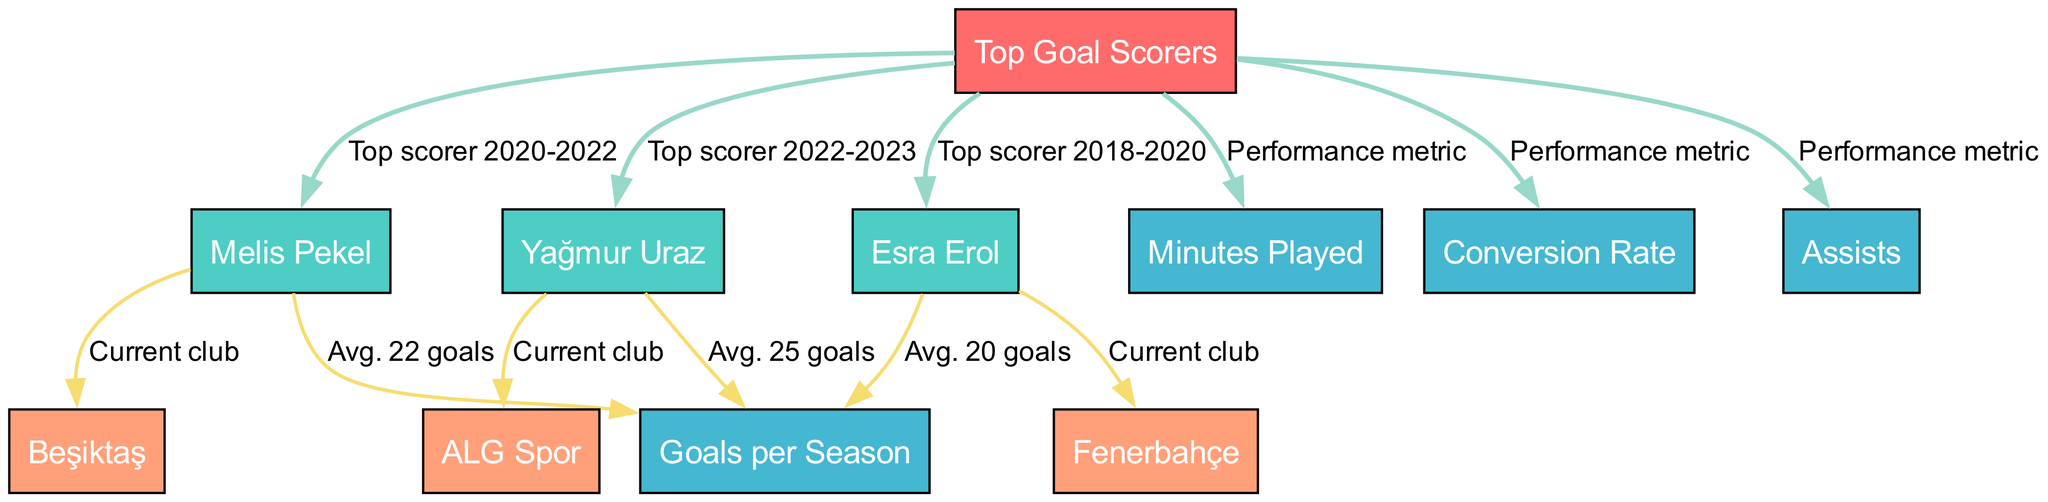What is the average number of goals scored by Melis Pekel? From the diagram, we can see that Melis Pekel has an average of 22 goals, as indicated by the edge connecting her node to the "Goals per Season" node.
Answer: 22 goals Who is the top scorer for the 2022-2023 season? The diagram shows that Yağmur Uraz is labeled as the top scorer for the 2022-2023 season, as indicated by the edge connecting her node to the "Top Goal Scorers" node.
Answer: Yağmur Uraz Which club does Esra Erol currently play for? According to the diagram, Esra Erol's node connects to "Fenerbahçe," indicating that she currently plays for this club.
Answer: Fenerbahçe How many performance metrics are represented in the diagram? The diagram includes three performance metrics: "Minutes Played," "Conversion Rate," and "Assists," which are all connected to the "Top Goal Scorers" node.
Answer: 3 Which player has the highest average goals? The diagram states that Yağmur Uraz has an average of 25 goals, which is higher than Melis Pekel's 22 goals and Esra Erol's 20 goals, as seen through their connections to the "Goals per Season" node.
Answer: Yağmur Uraz What is the relationship between Melis Pekel and her current club? The edge from Melis Pekel's node to "Beşiktaş" indicates that her current club is Beşiktaş, which establishes the connection between the player and the club.
Answer: Beşiktaş How many players are listed as top goal scorers? The diagram shows three players listed as top goal scorers: Melis Pekel, Yağmur Uraz, and Esra Erol. We can count the nodes connected to the "Top Goal Scorers" node to arrive at this number.
Answer: 3 What color represents the nodes for players in the diagram? The players' nodes, specifically Melis Pekel, Yağmur Uraz, and Esra Erol, are all colored with the same color (as indicated in the code), which is the second color on the palette.
Answer: Color 1 (with fill color matching the specified color in the diagram) Which player has an average of 20 goals? The connection from Esra Erol's node to the "Goals per Season" node indicates that she has an average of 20 goals, as labeled in the diagram.
Answer: 20 goals 